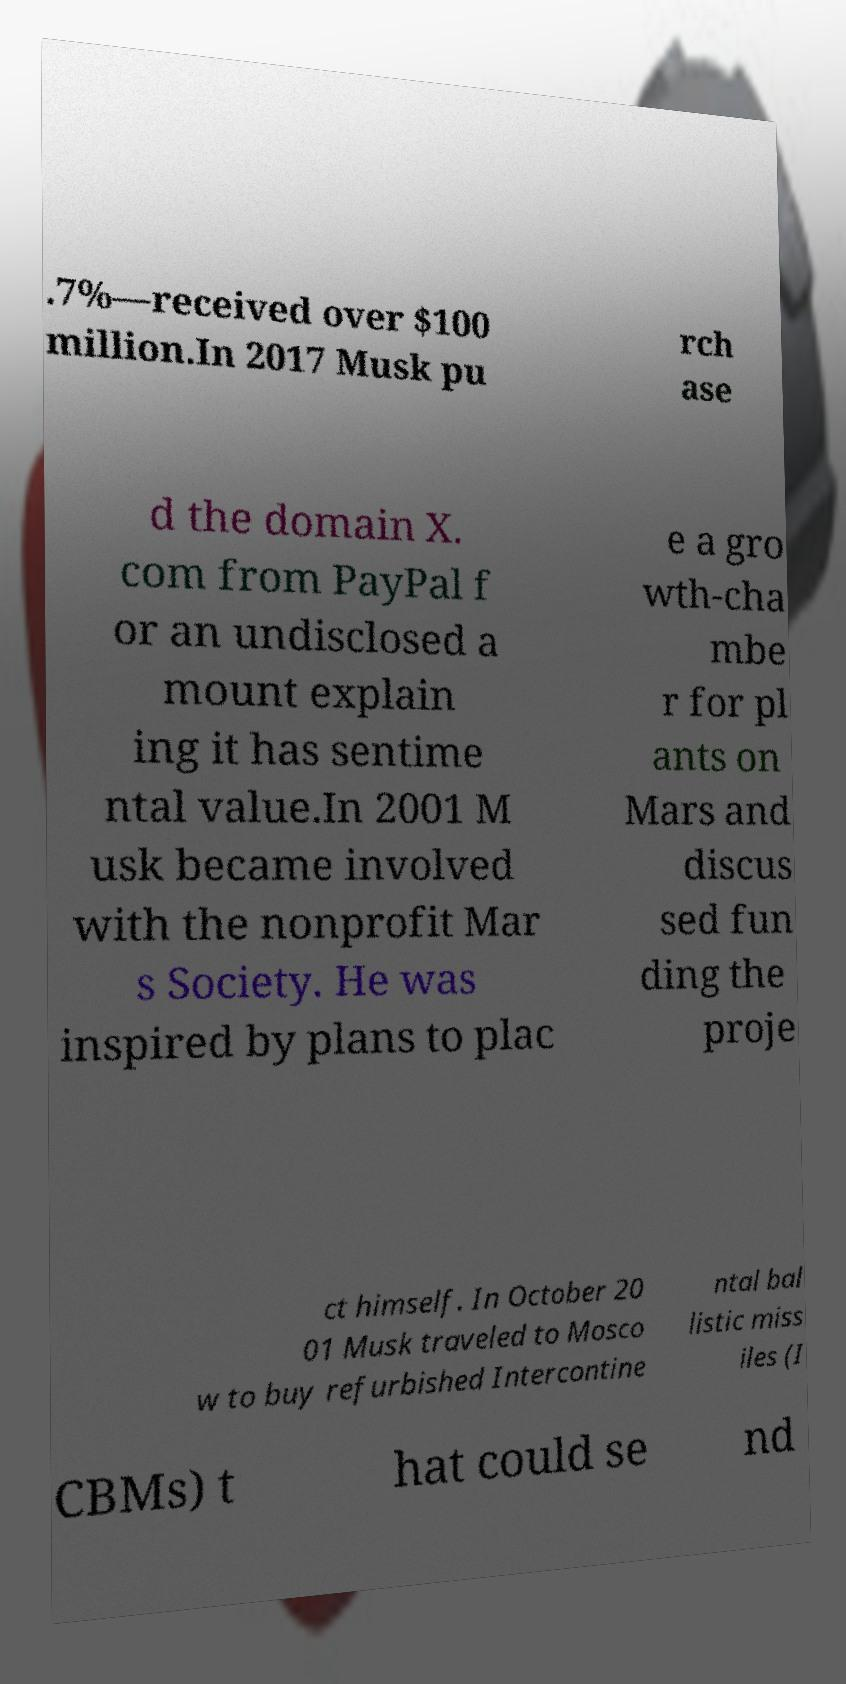Please identify and transcribe the text found in this image. .7%—received over $100 million.In 2017 Musk pu rch ase d the domain X. com from PayPal f or an undisclosed a mount explain ing it has sentime ntal value.In 2001 M usk became involved with the nonprofit Mar s Society. He was inspired by plans to plac e a gro wth-cha mbe r for pl ants on Mars and discus sed fun ding the proje ct himself. In October 20 01 Musk traveled to Mosco w to buy refurbished Intercontine ntal bal listic miss iles (I CBMs) t hat could se nd 